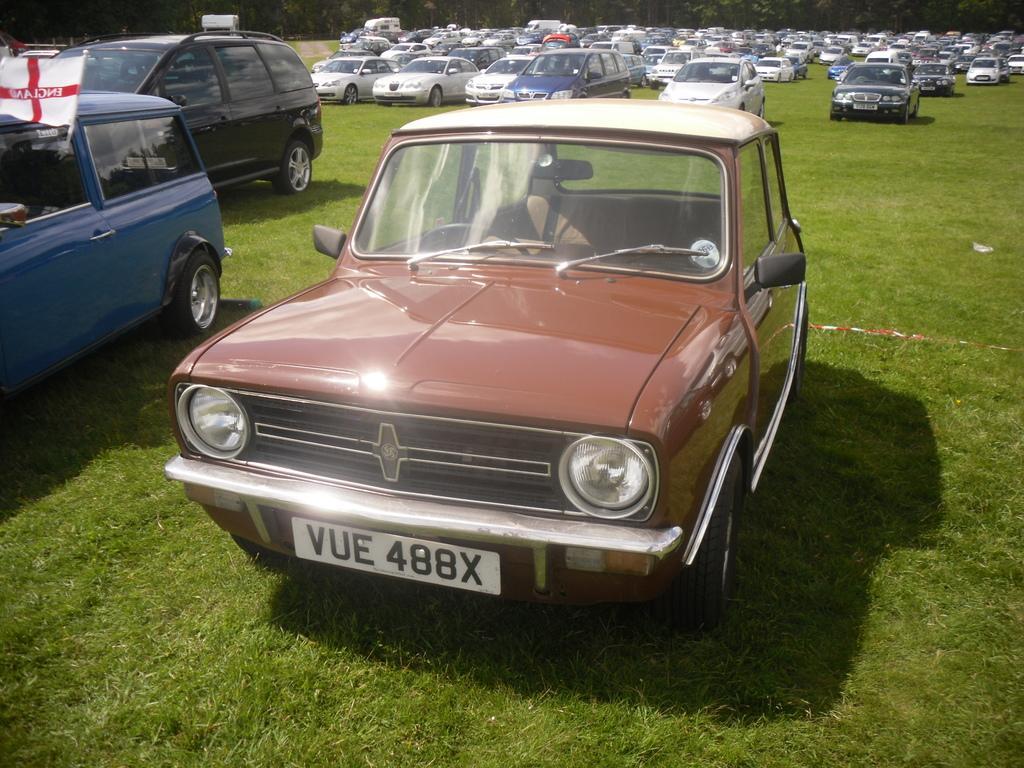Describe this image in one or two sentences. In this picture, we can see lots of vehicles are parked on the grass path and at the background there are trees. 